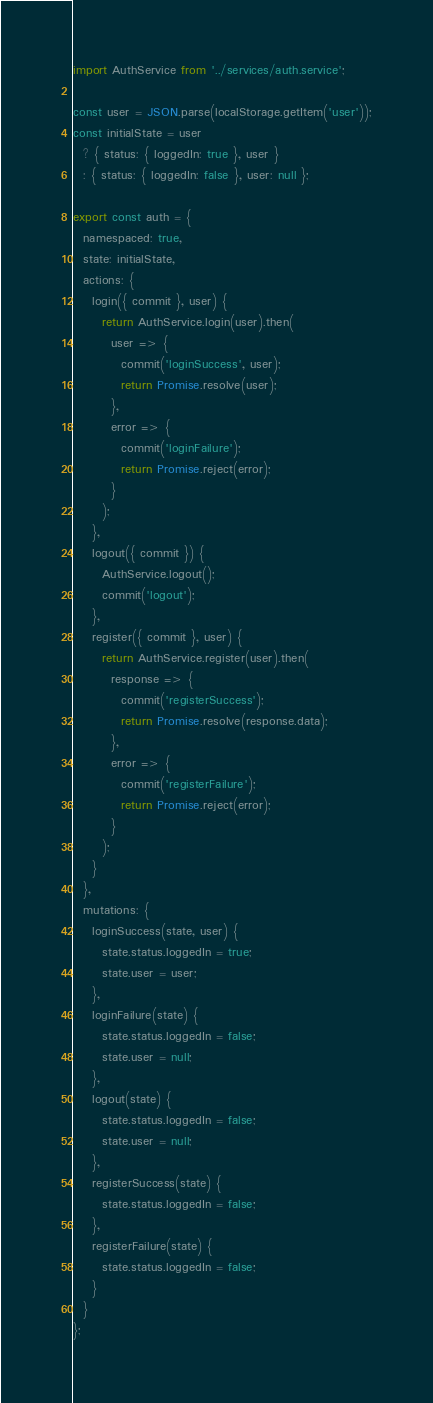Convert code to text. <code><loc_0><loc_0><loc_500><loc_500><_JavaScript_>import AuthService from '../services/auth.service';

const user = JSON.parse(localStorage.getItem('user'));
const initialState = user
  ? { status: { loggedIn: true }, user }
  : { status: { loggedIn: false }, user: null };

export const auth = {
  namespaced: true,
  state: initialState,
  actions: {
    login({ commit }, user) {
      return AuthService.login(user).then(
        user => {
          commit('loginSuccess', user);
          return Promise.resolve(user);
        },
        error => {
          commit('loginFailure');
          return Promise.reject(error);
        }
      );
    },
    logout({ commit }) {
      AuthService.logout();
      commit('logout');
    },
    register({ commit }, user) {
      return AuthService.register(user).then(
        response => {
          commit('registerSuccess');
          return Promise.resolve(response.data);
        },
        error => {
          commit('registerFailure');
          return Promise.reject(error);
        }
      );
    }
  },
  mutations: {
    loginSuccess(state, user) {
      state.status.loggedIn = true;
      state.user = user;
    },
    loginFailure(state) {
      state.status.loggedIn = false;
      state.user = null;
    },
    logout(state) {
      state.status.loggedIn = false;
      state.user = null;
    },
    registerSuccess(state) {
      state.status.loggedIn = false;
    },
    registerFailure(state) {
      state.status.loggedIn = false;
    }
  }
};</code> 